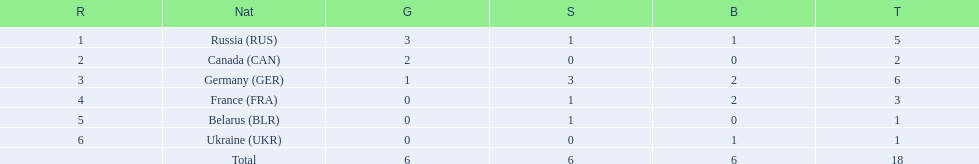What were all the countries that won biathlon medals? Russia (RUS), Canada (CAN), Germany (GER), France (FRA), Belarus (BLR), Ukraine (UKR). What were their medal counts? 5, 2, 6, 3, 1, 1. Of these, which is the largest number of medals? 6. Which country won this number of medals? Germany (GER). 